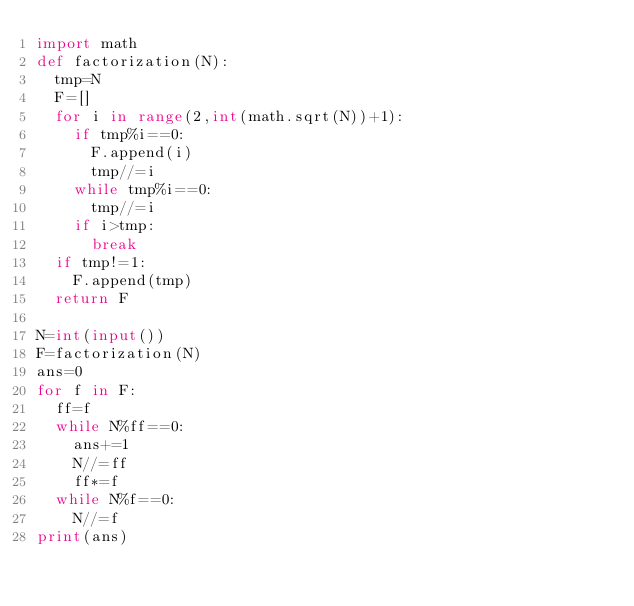Convert code to text. <code><loc_0><loc_0><loc_500><loc_500><_Python_>import math
def factorization(N):
  tmp=N
  F=[]
  for i in range(2,int(math.sqrt(N))+1):
    if tmp%i==0:
      F.append(i)
      tmp//=i
    while tmp%i==0:
      tmp//=i
    if i>tmp:
      break
  if tmp!=1:
    F.append(tmp)
  return F

N=int(input())
F=factorization(N)
ans=0
for f in F:
  ff=f
  while N%ff==0:
    ans+=1
    N//=ff
    ff*=f
  while N%f==0:
    N//=f
print(ans)</code> 